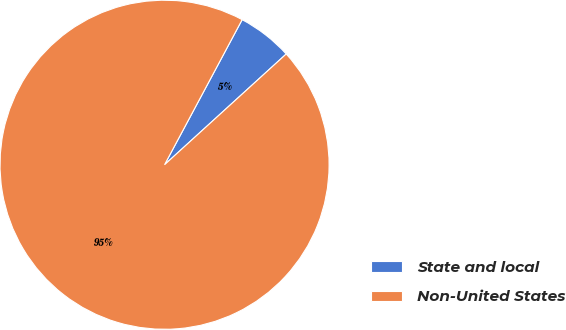<chart> <loc_0><loc_0><loc_500><loc_500><pie_chart><fcel>State and local<fcel>Non-United States<nl><fcel>5.43%<fcel>94.57%<nl></chart> 